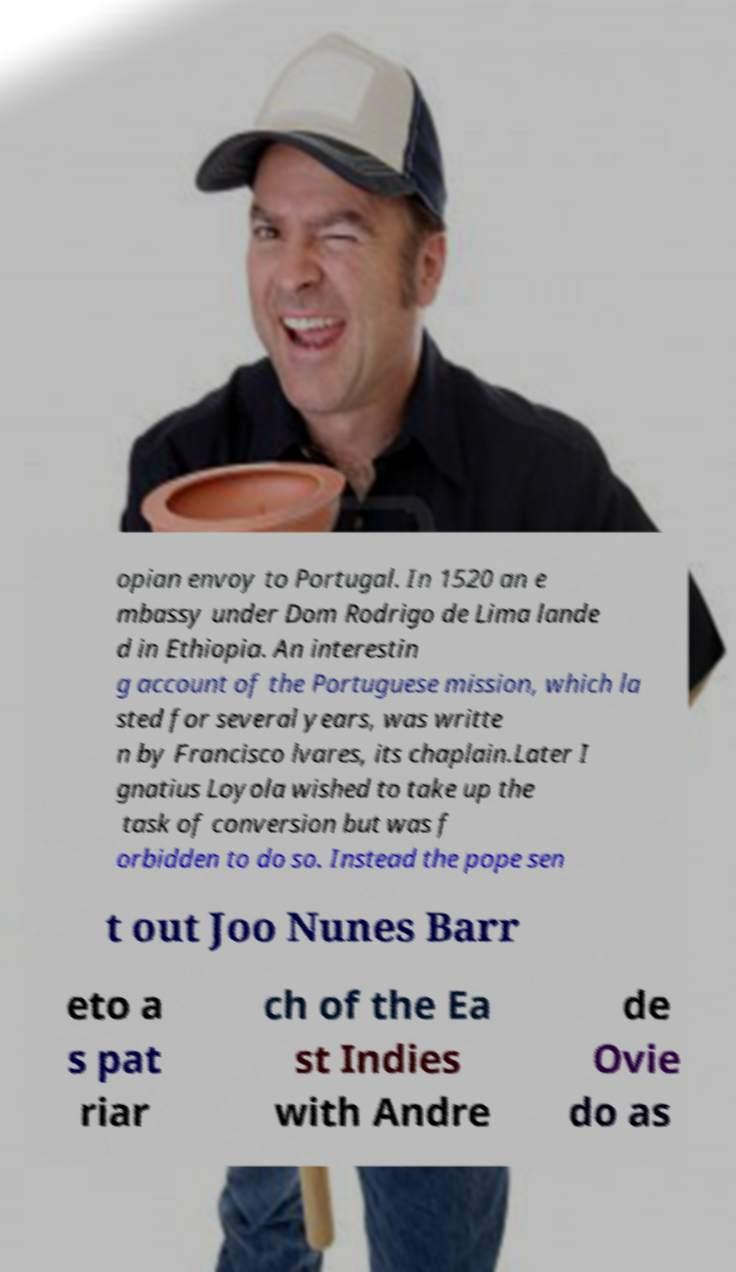Please identify and transcribe the text found in this image. opian envoy to Portugal. In 1520 an e mbassy under Dom Rodrigo de Lima lande d in Ethiopia. An interestin g account of the Portuguese mission, which la sted for several years, was writte n by Francisco lvares, its chaplain.Later I gnatius Loyola wished to take up the task of conversion but was f orbidden to do so. Instead the pope sen t out Joo Nunes Barr eto a s pat riar ch of the Ea st Indies with Andre de Ovie do as 